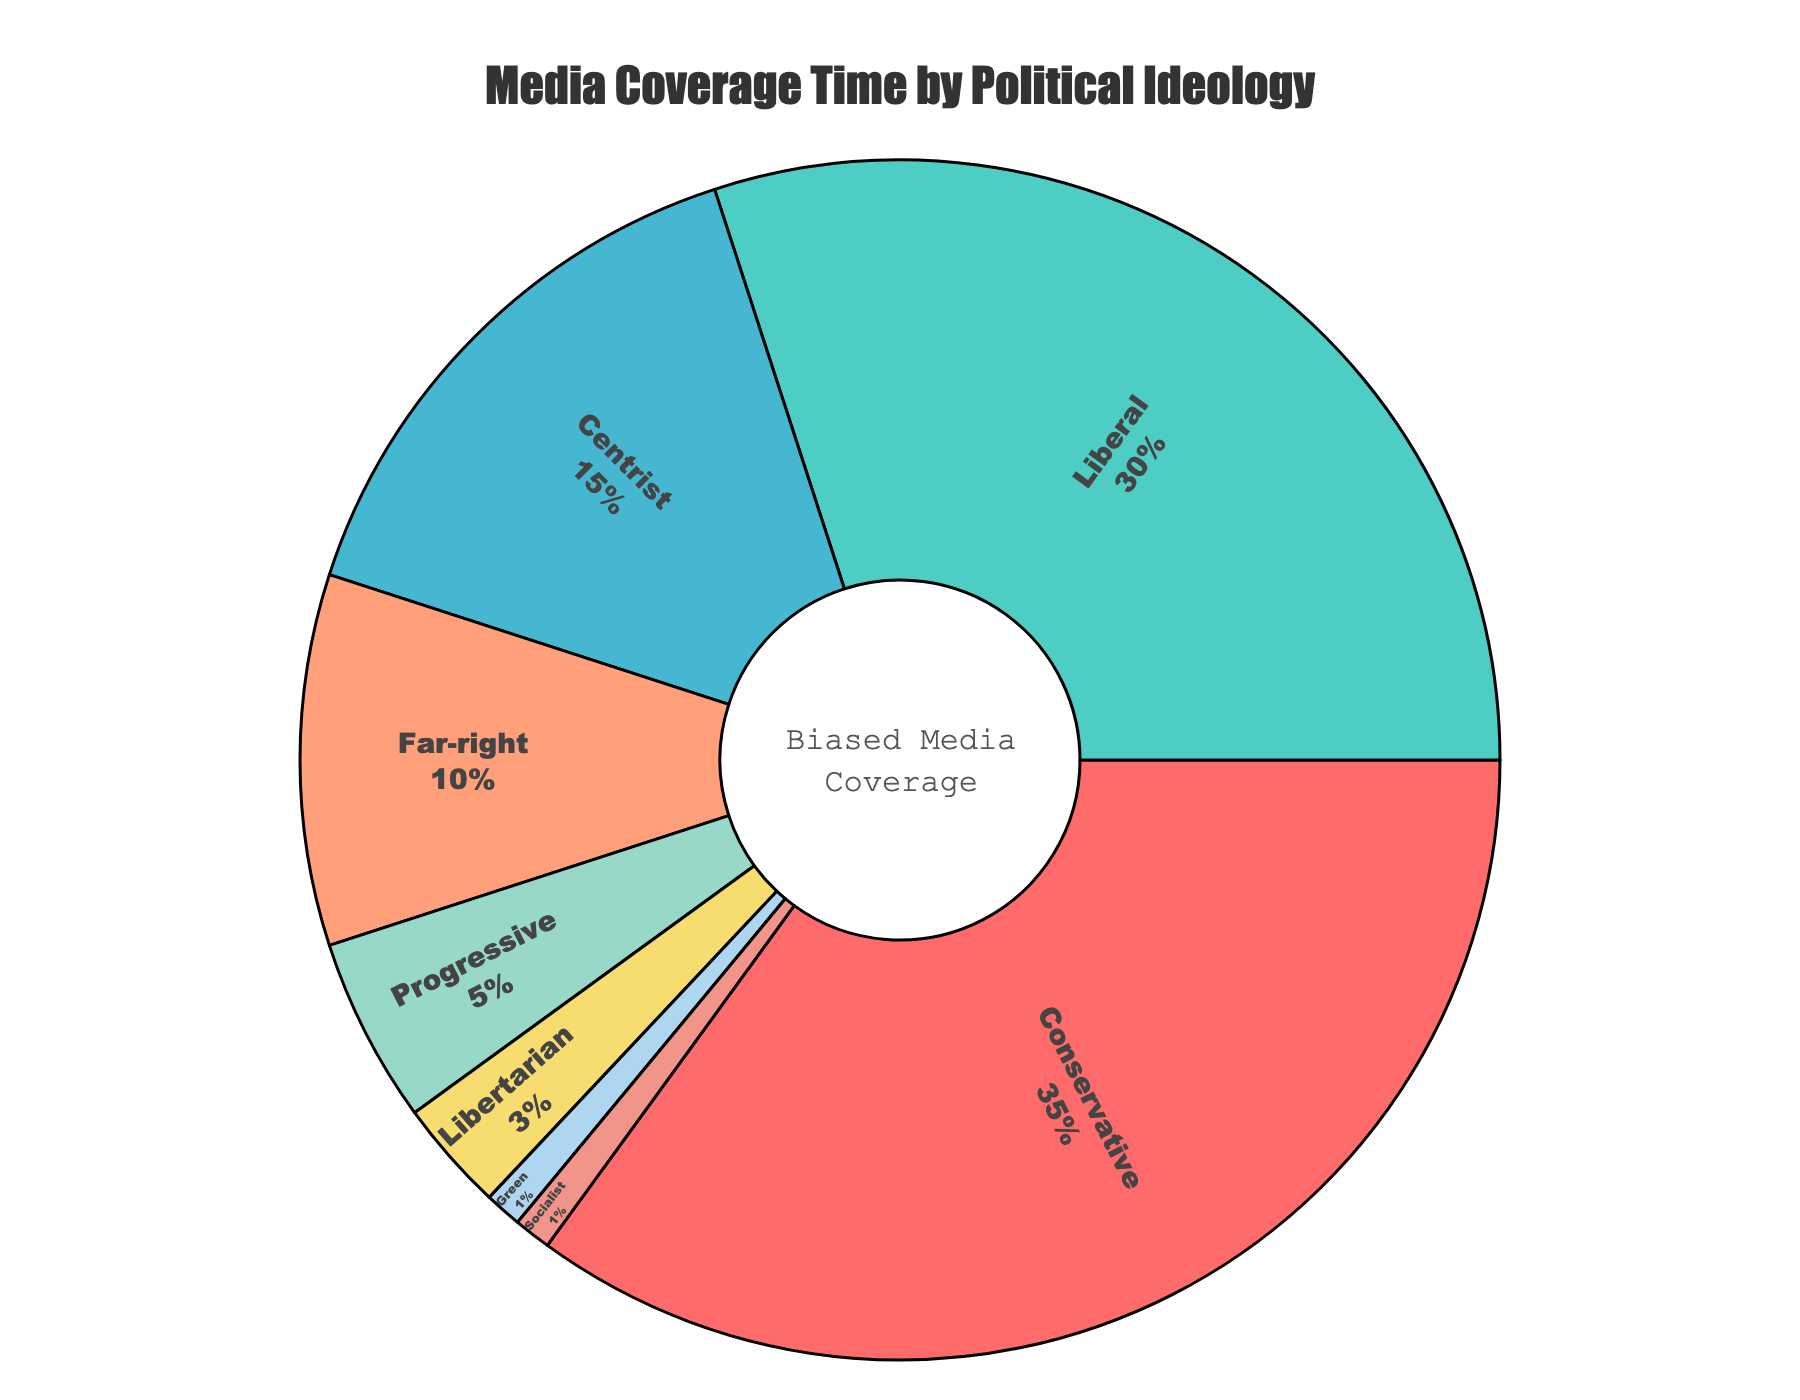What percentage of media coverage time is given to Conservative and Liberal ideologies combined? Sum the percentages of media coverage time for Conservative (35%) and Liberal (30%) ideologies. 35 + 30 = 65.
Answer: 65% Which political ideology receives the least media coverage time? The Green and Socialist ideologies both have the smallest percentage of media coverage time at 1%.
Answer: Green and Socialist (both 1%) How much more media coverage time does the Conservative ideology receive compared to the Centrist ideology? Subtract the percentage of media coverage time for Centrist (15%) from Conservative (35%). 35 - 15 = 20.
Answer: 20% Which ideologies together account for more than half of the total media coverage time? Sum the top values until the cumulative percentage exceeds 50%. Conservative (35%) + Liberal (30%) = 65%.
Answer: Conservative and Liberal What color represents the Libertarian ideology in the pie chart? The Libertarian ideology is represented in the pie chart by the slice colored yellow.
Answer: Yellow If media coverage time for Progressive were to be doubled, what would its new percentage be? Multiply the current percentage for Progressive (5%) by 2. 5 x 2 = 10.
Answer: 10% Compare the media coverage time of Far-right and Progressive ideologies in difference. Subtract the percentage of media coverage time for Progressive (5%) from Far-right (10%). 10 - 5 = 5.
Answer: 5% List the ideologies covered by less than 10% of the media coverage time. Identify the ideologies with percentages less than 10%. Far-right (10%), Progressive (5%), Libertarian (3%), Green (1%), Socialist (1%). The ideologies that are less than 10% are Progressive, Libertarian, Green, and Socialist.
Answer: Progressive, Libertarian, Green, and Socialist What is the total media coverage time for ideologies that receive 15% or less of the coverage each? Sum the percentages of media coverage time for Centrist (15%), Far-right (10%), Progressive (5%), Libertarian (3%), Green (1%), and Socialist (1%). 15 + 10 + 5 + 3 + 1 + 1 = 35.
Answer: 35% What portion of the pie chart is not covered by Conservative and Liberal ideologies? Subtract the combined percentage of Conservative (35%) and Liberal (30%) from 100%. 100 - (35 + 30) = 35.
Answer: 35% 